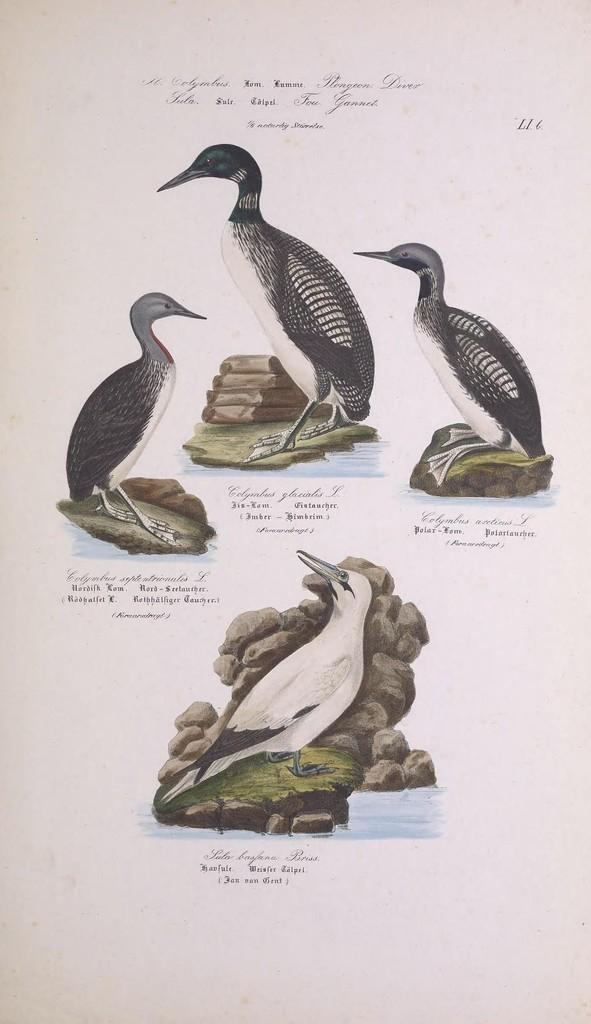What is depicted on the paper in the image? The paper contains pictures of birds, stones, grass, and water. Can you describe the content of the pictures on the paper? The pictures on the paper depict birds, stones, grass, and water. What is the primary focus of the images on the paper? The primary focus of the images on the paper is nature, as they depict birds, stones, grass, and water. What type of silk is used to make the ship visible in the image? There is no ship present in the image, and silk is not mentioned in the provided facts. 